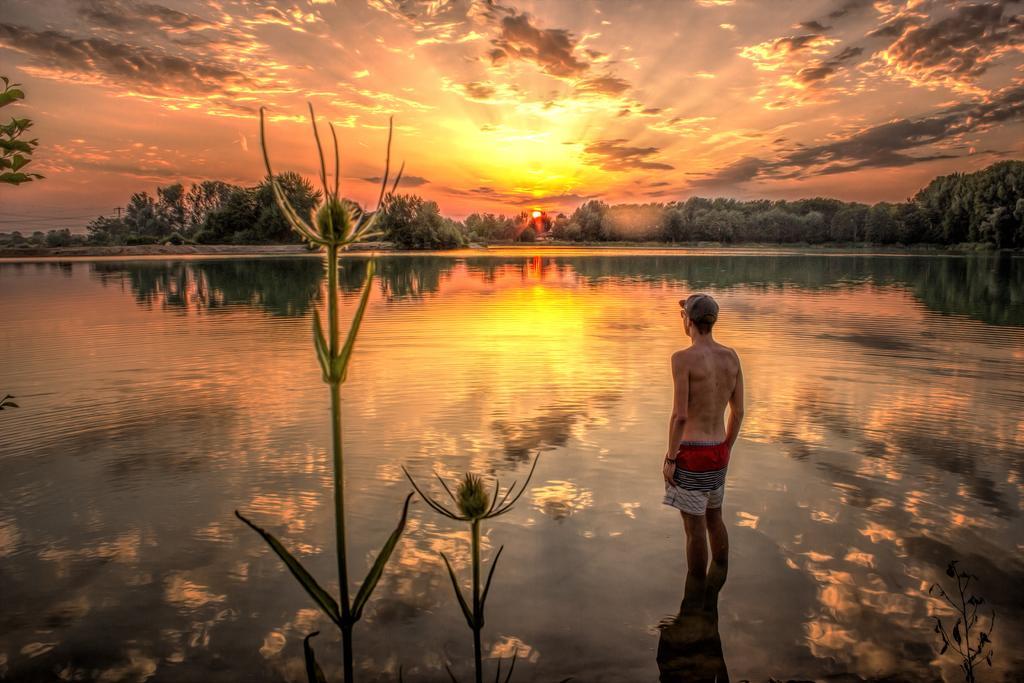In one or two sentences, can you explain what this image depicts? In this picture I can see a man standing in the water, there are trees, and in the background there is the sky. 